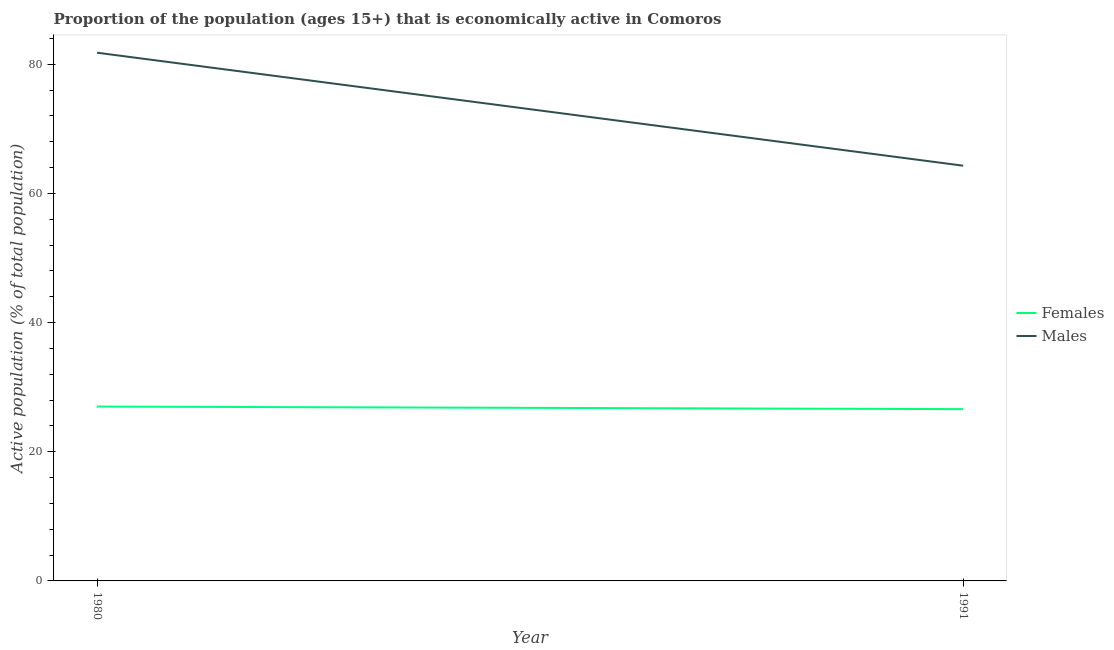Does the line corresponding to percentage of economically active female population intersect with the line corresponding to percentage of economically active male population?
Your response must be concise. No. What is the percentage of economically active male population in 1991?
Provide a succinct answer. 64.3. Across all years, what is the maximum percentage of economically active male population?
Make the answer very short. 81.8. Across all years, what is the minimum percentage of economically active female population?
Give a very brief answer. 26.6. In which year was the percentage of economically active female population maximum?
Your answer should be compact. 1980. What is the total percentage of economically active female population in the graph?
Keep it short and to the point. 53.6. What is the difference between the percentage of economically active male population in 1980 and that in 1991?
Provide a short and direct response. 17.5. What is the difference between the percentage of economically active male population in 1980 and the percentage of economically active female population in 1991?
Keep it short and to the point. 55.2. What is the average percentage of economically active male population per year?
Provide a short and direct response. 73.05. In the year 1980, what is the difference between the percentage of economically active male population and percentage of economically active female population?
Provide a succinct answer. 54.8. What is the ratio of the percentage of economically active female population in 1980 to that in 1991?
Ensure brevity in your answer.  1.02. Is the percentage of economically active male population in 1980 less than that in 1991?
Your answer should be very brief. No. In how many years, is the percentage of economically active female population greater than the average percentage of economically active female population taken over all years?
Give a very brief answer. 1. Is the percentage of economically active male population strictly greater than the percentage of economically active female population over the years?
Ensure brevity in your answer.  Yes. How many lines are there?
Your response must be concise. 2. How many years are there in the graph?
Provide a short and direct response. 2. Are the values on the major ticks of Y-axis written in scientific E-notation?
Keep it short and to the point. No. Does the graph contain any zero values?
Your answer should be very brief. No. Does the graph contain grids?
Ensure brevity in your answer.  No. How are the legend labels stacked?
Make the answer very short. Vertical. What is the title of the graph?
Offer a terse response. Proportion of the population (ages 15+) that is economically active in Comoros. What is the label or title of the X-axis?
Make the answer very short. Year. What is the label or title of the Y-axis?
Your response must be concise. Active population (% of total population). What is the Active population (% of total population) in Males in 1980?
Offer a very short reply. 81.8. What is the Active population (% of total population) in Females in 1991?
Provide a succinct answer. 26.6. What is the Active population (% of total population) of Males in 1991?
Provide a succinct answer. 64.3. Across all years, what is the maximum Active population (% of total population) in Males?
Provide a succinct answer. 81.8. Across all years, what is the minimum Active population (% of total population) of Females?
Give a very brief answer. 26.6. Across all years, what is the minimum Active population (% of total population) of Males?
Keep it short and to the point. 64.3. What is the total Active population (% of total population) of Females in the graph?
Provide a succinct answer. 53.6. What is the total Active population (% of total population) of Males in the graph?
Keep it short and to the point. 146.1. What is the difference between the Active population (% of total population) in Females in 1980 and the Active population (% of total population) in Males in 1991?
Provide a succinct answer. -37.3. What is the average Active population (% of total population) of Females per year?
Provide a short and direct response. 26.8. What is the average Active population (% of total population) in Males per year?
Keep it short and to the point. 73.05. In the year 1980, what is the difference between the Active population (% of total population) of Females and Active population (% of total population) of Males?
Your response must be concise. -54.8. In the year 1991, what is the difference between the Active population (% of total population) in Females and Active population (% of total population) in Males?
Give a very brief answer. -37.7. What is the ratio of the Active population (% of total population) of Males in 1980 to that in 1991?
Offer a terse response. 1.27. What is the difference between the highest and the lowest Active population (% of total population) of Females?
Your response must be concise. 0.4. 